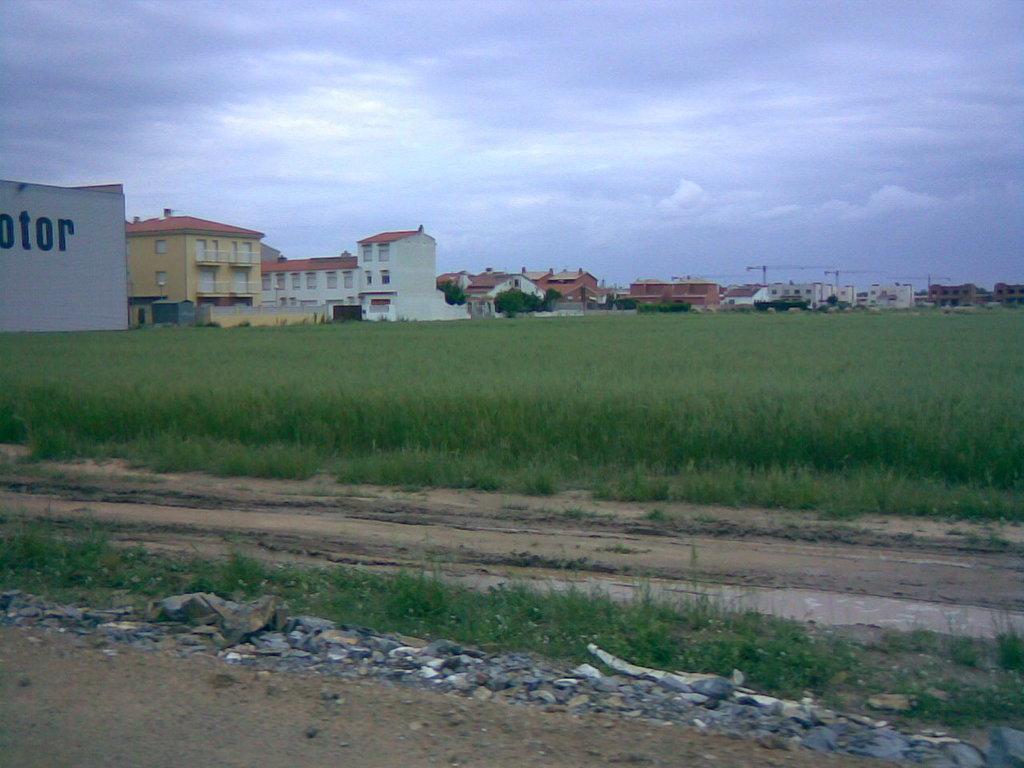How would you summarize this image in a sentence or two? These are the buildings with the windows. In the background, I can see the tower cranes. These are the rocks. I think these are the fields. Here is the sky. 